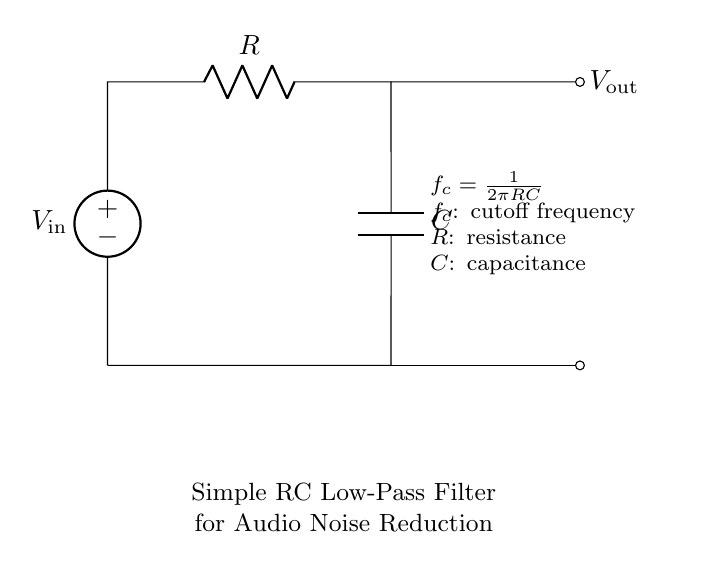What are the components of this circuit? The components consist of a voltage source, a resistor, and a capacitor. These are indicated by their respective symbols in the diagram.
Answer: Voltage source, resistor, capacitor What is the function of the resistor in this circuit? The resistor controls the current flow and influences the cutoff frequency of the filter, providing a means to adjust the filter's response to different frequencies.
Answer: Control current flow, adjust cutoff frequency What is the output voltage notation in this circuit? The output voltage is denoted as V out, showing the voltage across the capacitor where the filtered signal is taken.
Answer: V out What is the cutoff frequency formula provided in the circuit? The circuit includes the formula f c = 1 / (2πRC) as the cutoff frequency, which defines the frequency at which the output voltage is reduced by 3 dB.
Answer: f c = 1 / (2πRC) How does the value of the resistor affect the filter's performance? Increasing the resistance will lower the cutoff frequency, which means that the filter will allow fewer high-frequency signals to pass through, thus affecting audio quality. Conversely, decreasing resistance will raise the cutoff frequency.
Answer: Lowering cutoff frequency What does the capacitor do in this circuit? The capacitor in this circuit allows AC signals to pass while blocking DC signals. This property is essential for filtering out unwanted noise from audio signals.
Answer: Block DC, allow AC What happens if the capacitance value is increased? Increasing the capacitance will lower the cutoff frequency, allowing more low-frequency signals to pass through while attenuating higher frequencies, affecting the noise reduction characteristics of the filter.
Answer: Lowers cutoff frequency 